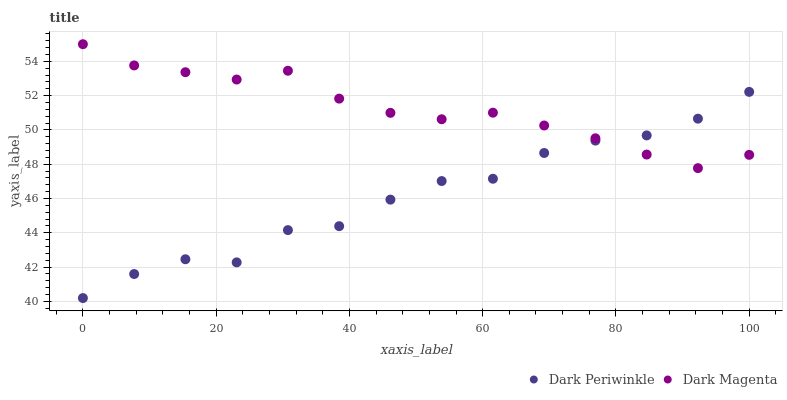Does Dark Periwinkle have the minimum area under the curve?
Answer yes or no. Yes. Does Dark Magenta have the maximum area under the curve?
Answer yes or no. Yes. Does Dark Magenta have the minimum area under the curve?
Answer yes or no. No. Is Dark Magenta the smoothest?
Answer yes or no. Yes. Is Dark Periwinkle the roughest?
Answer yes or no. Yes. Is Dark Magenta the roughest?
Answer yes or no. No. Does Dark Periwinkle have the lowest value?
Answer yes or no. Yes. Does Dark Magenta have the lowest value?
Answer yes or no. No. Does Dark Magenta have the highest value?
Answer yes or no. Yes. Does Dark Periwinkle intersect Dark Magenta?
Answer yes or no. Yes. Is Dark Periwinkle less than Dark Magenta?
Answer yes or no. No. Is Dark Periwinkle greater than Dark Magenta?
Answer yes or no. No. 